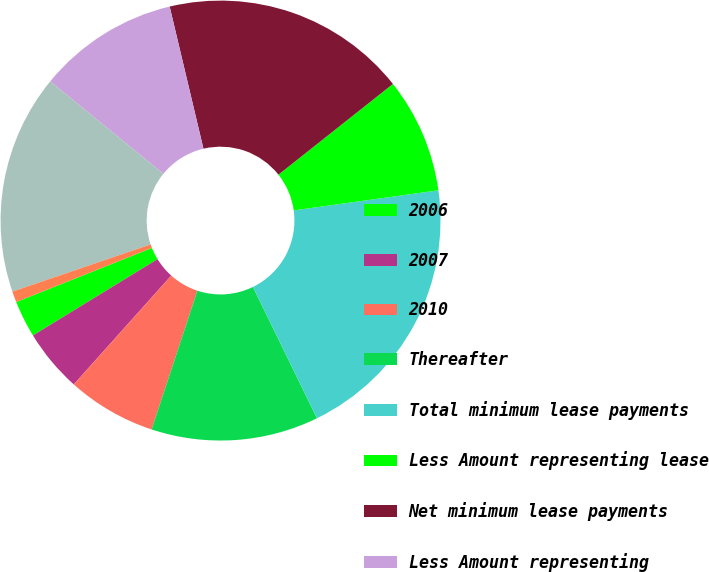Convert chart to OTSL. <chart><loc_0><loc_0><loc_500><loc_500><pie_chart><fcel>2006<fcel>2007<fcel>2010<fcel>Thereafter<fcel>Total minimum lease payments<fcel>Less Amount representing lease<fcel>Net minimum lease payments<fcel>Less Amount representing<fcel>Present value of net minimum<fcel>Less Current portion<nl><fcel>2.71%<fcel>4.63%<fcel>6.55%<fcel>12.3%<fcel>19.97%<fcel>8.47%<fcel>18.05%<fcel>10.38%<fcel>16.14%<fcel>0.8%<nl></chart> 